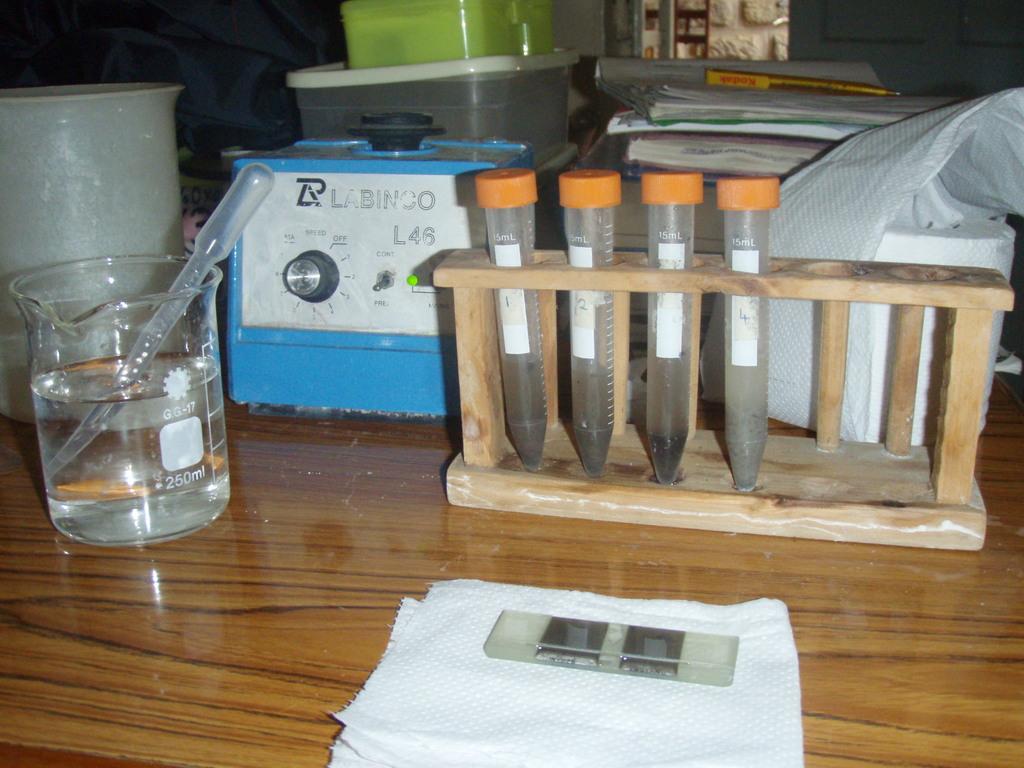How many ml does the beaker hold?
Make the answer very short. 250. 